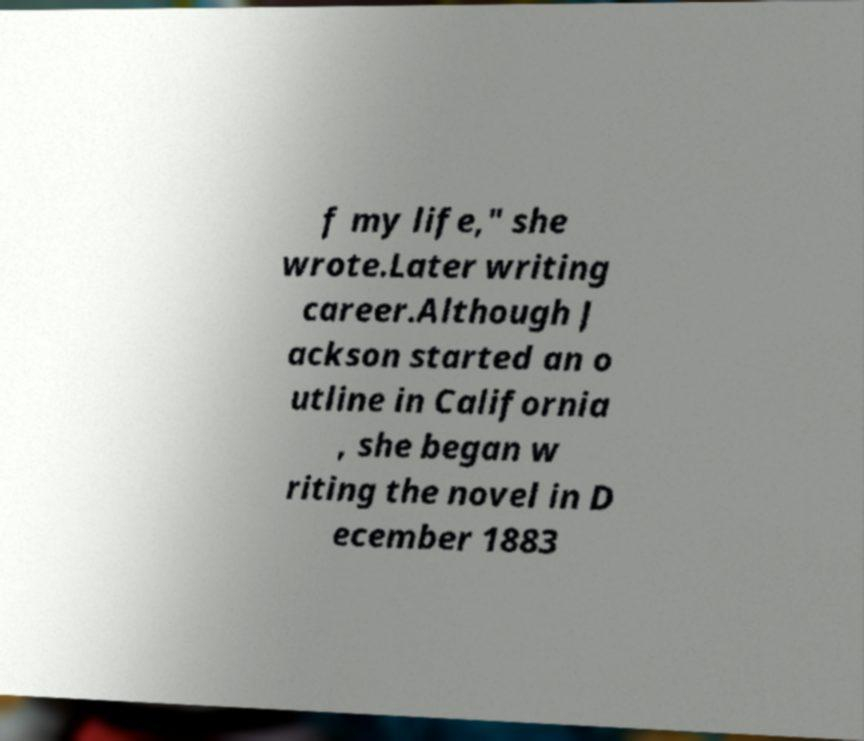Please identify and transcribe the text found in this image. f my life," she wrote.Later writing career.Although J ackson started an o utline in California , she began w riting the novel in D ecember 1883 